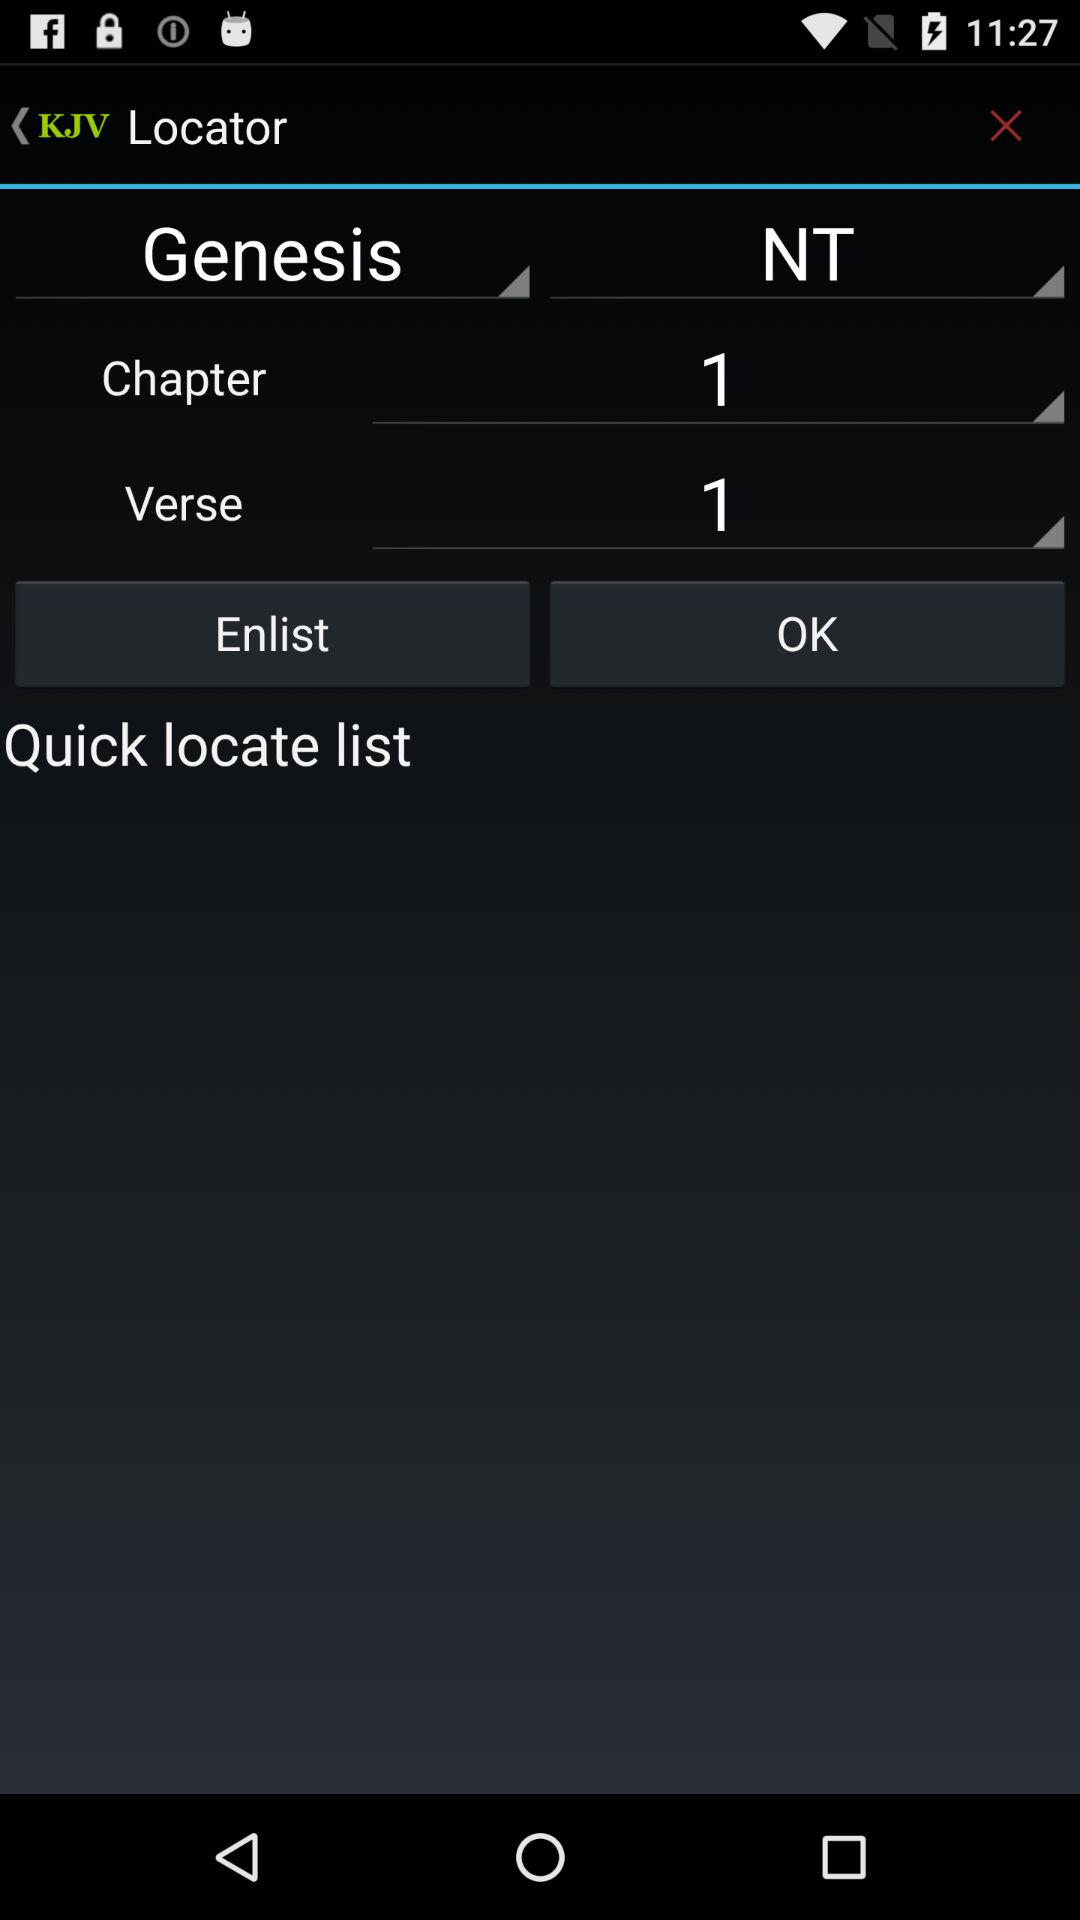Who is this application powered by?
When the provided information is insufficient, respond with <no answer>. <no answer> 